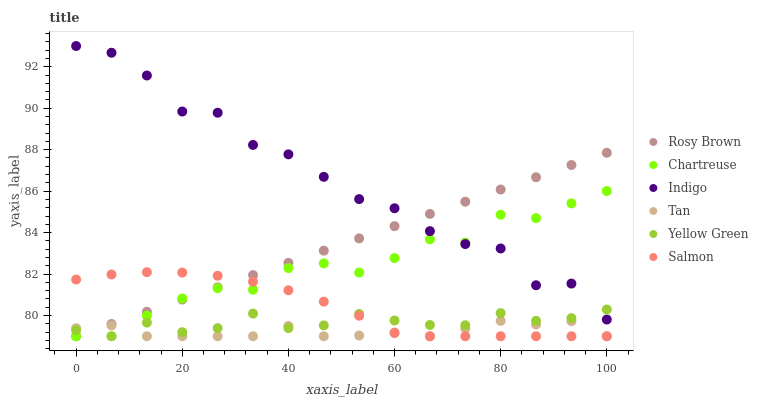Does Tan have the minimum area under the curve?
Answer yes or no. Yes. Does Indigo have the maximum area under the curve?
Answer yes or no. Yes. Does Yellow Green have the minimum area under the curve?
Answer yes or no. No. Does Yellow Green have the maximum area under the curve?
Answer yes or no. No. Is Rosy Brown the smoothest?
Answer yes or no. Yes. Is Indigo the roughest?
Answer yes or no. Yes. Is Yellow Green the smoothest?
Answer yes or no. No. Is Yellow Green the roughest?
Answer yes or no. No. Does Yellow Green have the lowest value?
Answer yes or no. Yes. Does Indigo have the highest value?
Answer yes or no. Yes. Does Yellow Green have the highest value?
Answer yes or no. No. Is Salmon less than Indigo?
Answer yes or no. Yes. Is Indigo greater than Salmon?
Answer yes or no. Yes. Does Yellow Green intersect Tan?
Answer yes or no. Yes. Is Yellow Green less than Tan?
Answer yes or no. No. Is Yellow Green greater than Tan?
Answer yes or no. No. Does Salmon intersect Indigo?
Answer yes or no. No. 